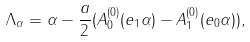<formula> <loc_0><loc_0><loc_500><loc_500>\Lambda _ { \alpha } = \alpha - \frac { a } { 2 } ( A ^ { ( 0 ) } _ { 0 } ( e _ { 1 } \alpha ) - A ^ { ( 0 ) } _ { 1 } ( e _ { 0 } \alpha ) ) ,</formula> 